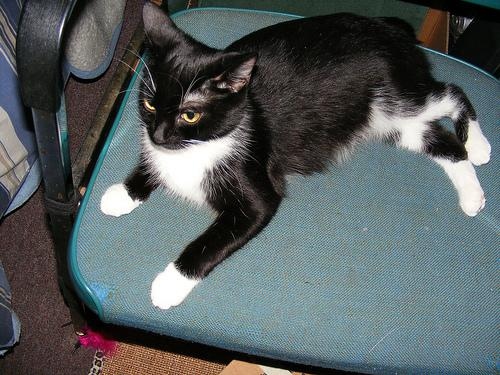Identify the primary object in the picture and specify its characteristics. The primary object is a black and white cat with yellow eyes, lying on a chair with a blue seat cushion. Briefly describe the primary animal in this image and their distinct features. The primary animal is a black cat with white paws, yellow eyes, and white whiskers, reclining on a chair. Explain the main focus of this image, along with any key features. The main focus of the image is a black and white cat with yellow eyes; it's lying on a blue cushioned chair. Tell us about the animal in the image and its unique character traits. The image features a black cat with white paws, yellow eyes, white whiskers, and an open eye, lying on a chair. Mention the most prominent object in the image and its distinctive features. The most prominent object is a black cat with white paws and yellow eyes, lounging on a chair. State the central subject of the image and its specific attributes. The central subject is a black cat with white paws, yellow eyes, and white whiskers, lying comfortably on a chair. Describe the setting and the most notable features of the main subject in the image. The setting is a room with a cat lying on a chair. The cat is black with white paws and yellow eyes. What kind of animal is pictured, and what unique features does it have? The animal is a black and white cat with distinctive yellow eyes, white whiskers, and open eyes, resting on a chair. Provide a brief description of the main animal in the image along with its features. A black cat with white paws and yellow eyes can be seen resting on a chair with its head and paws visible. What color are the cat's eyes and where is it laying? The cat has yellow eyes and is lying on a chair with a blue seat cushion. 